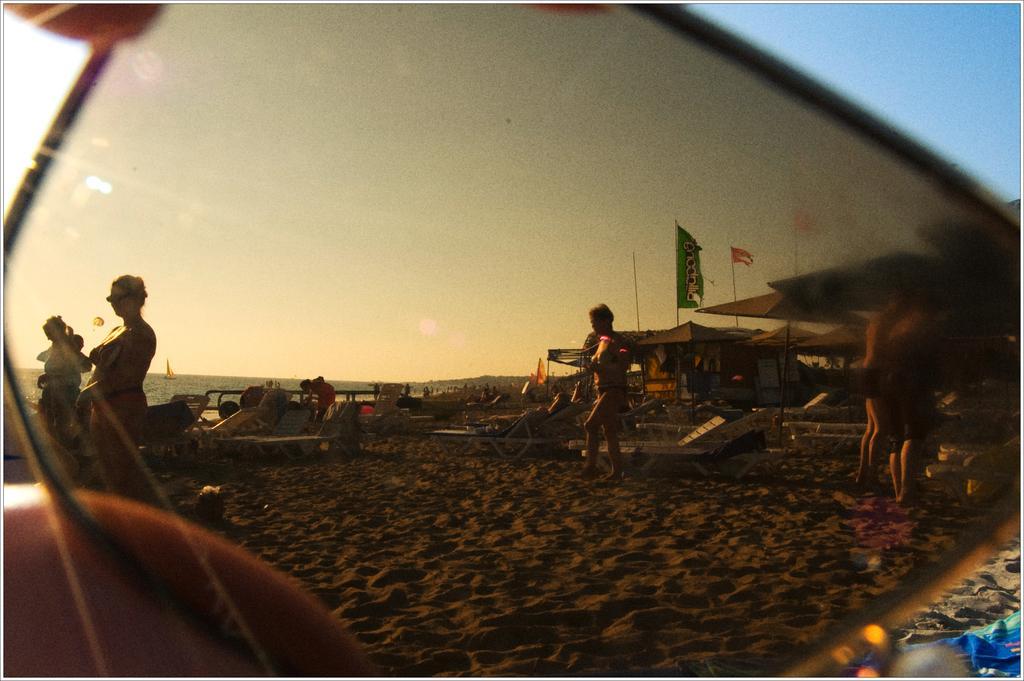How would you summarize this image in a sentence or two? In this picture we can observe a mirror. In the mirror there are some people. We can observe men and women in the beach. In the background there is an ocean. On the right side we can observe tents and some flags. In the background there is a sky. 